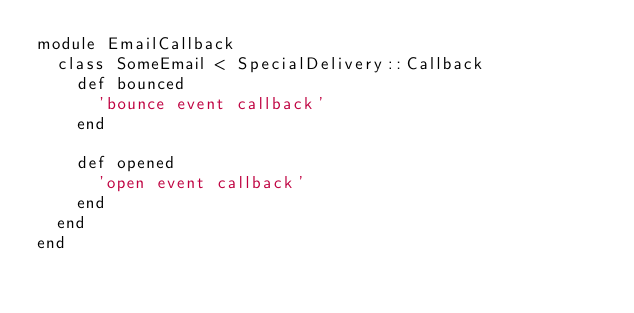<code> <loc_0><loc_0><loc_500><loc_500><_Ruby_>module EmailCallback
  class SomeEmail < SpecialDelivery::Callback
    def bounced
      'bounce event callback'
    end

    def opened
      'open event callback'
    end
  end
end
</code> 